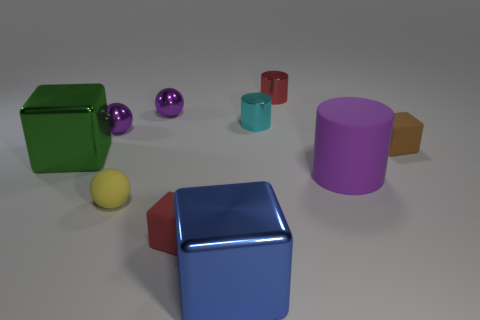Subtract all metallic spheres. How many spheres are left? 1 Subtract all brown cubes. How many purple spheres are left? 2 Subtract all red cylinders. How many cylinders are left? 2 Subtract all spheres. How many objects are left? 7 Subtract 2 cylinders. How many cylinders are left? 1 Subtract all cyan blocks. Subtract all blue cylinders. How many blocks are left? 4 Subtract all large brown cylinders. Subtract all purple cylinders. How many objects are left? 9 Add 2 large matte objects. How many large matte objects are left? 3 Add 7 tiny matte blocks. How many tiny matte blocks exist? 9 Subtract 0 brown spheres. How many objects are left? 10 